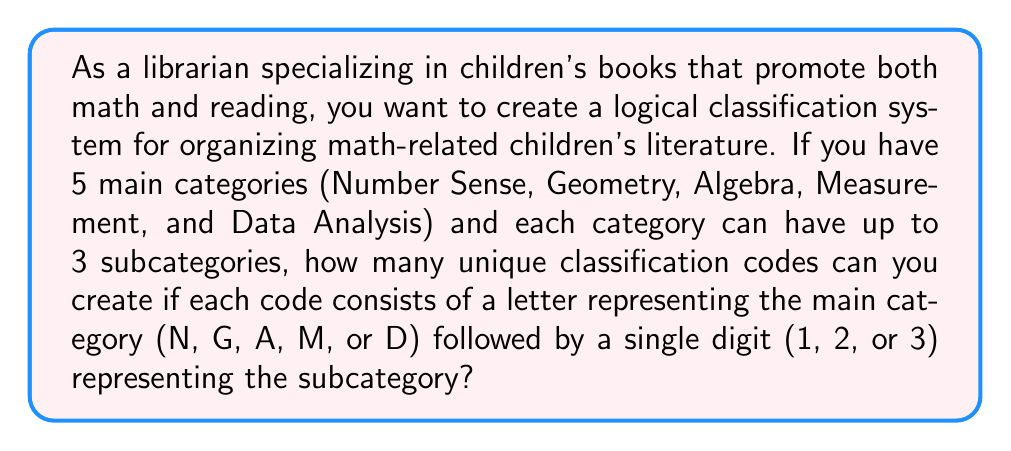Teach me how to tackle this problem. To solve this problem, we'll use the multiplication principle of counting. Let's break it down step-by-step:

1. First, let's consider the main categories:
   There are 5 main categories, each represented by a letter (N, G, A, M, or D).

2. Next, let's look at the subcategories:
   Each main category can have up to 3 subcategories, represented by the digits 1, 2, or 3.

3. Now, we need to determine how many unique combinations we can create:
   - For each main category, we have 3 possible subcategories.
   - We have 5 main categories in total.

4. According to the multiplication principle, if we have m ways of doing something and n ways of doing another thing, then there are m × n ways of doing both things.

5. In this case, we have:
   - 5 choices for the main category
   - 3 choices for the subcategory

6. Therefore, the total number of unique classification codes is:

   $$ 5 \times 3 = 15 $$

This means we can create 15 unique classification codes for organizing math-related children's literature based on the given logical categories.
Answer: 15 unique classification codes 